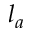Convert formula to latex. <formula><loc_0><loc_0><loc_500><loc_500>l _ { a }</formula> 